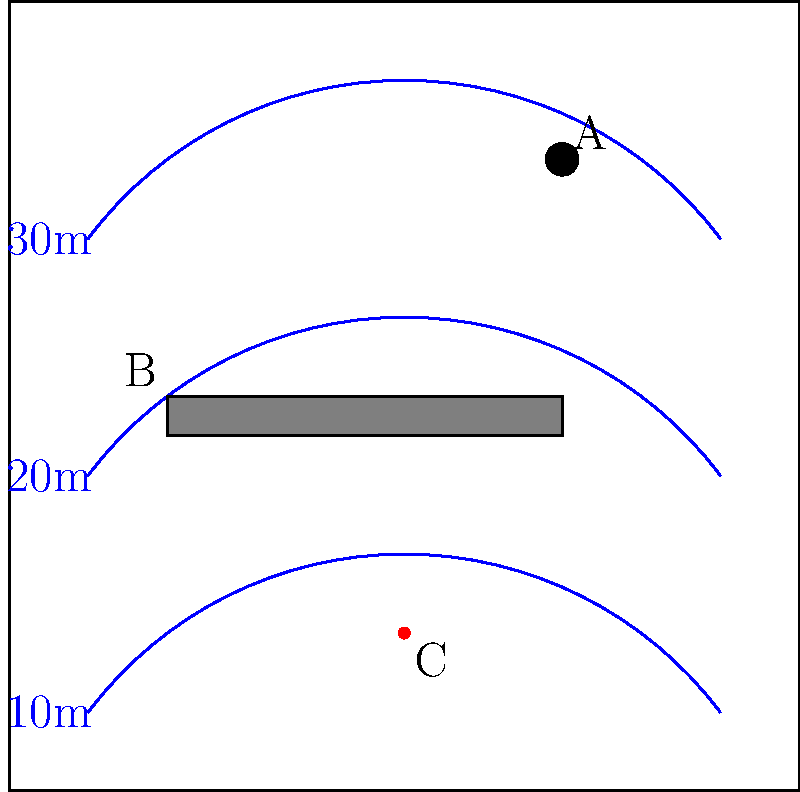In the provided navigational chart, three key elements are labeled A, B, and C. For maritime legal purposes, identify which of these elements represents a potential navigational hazard that should be avoided by large vessels, and explain the reasoning behind your choice. To answer this question, we need to analyze each element on the chart:

1. Element A: This is represented by a small filled circle. In standard nautical chart symbology, this typically indicates a fixed navigational aid, such as a buoy or beacon. While important for navigation, it is not inherently a hazard.

2. Element B: This is shown as a rectangular gray area. In nautical charts, such areas often represent shoals, sandbars, or other shallow areas. These can be hazardous to large vessels with deep drafts.

3. Element C: This is depicted as a red dot. In maritime charts, isolated red dots often indicate specific dangers such as rocks, wrecks, or other obstructions that may be submerged or partially submerged.

4. Depth contours: The blue lines represent depth contours, with the shallowest areas (10m) closest to the bottom of the chart and deeper areas (30m) towards the top.

Given this analysis, both elements B and C could potentially represent navigational hazards. However, element C is more likely to be an immediate danger:

- It is represented by a distinct red dot, which is commonly used to highlight specific hazards.
- It is located in an area between the 10m and 20m depth contours, indicating it could be a relatively shallow obstruction.
- Its isolated nature suggests it could be an unexpected danger, unlike the larger area represented by element B.

Therefore, from a maritime legal perspective, element C represents the most significant potential navigational hazard that large vessels should avoid.
Answer: Element C (red dot), likely indicating a specific underwater hazard in relatively shallow water. 